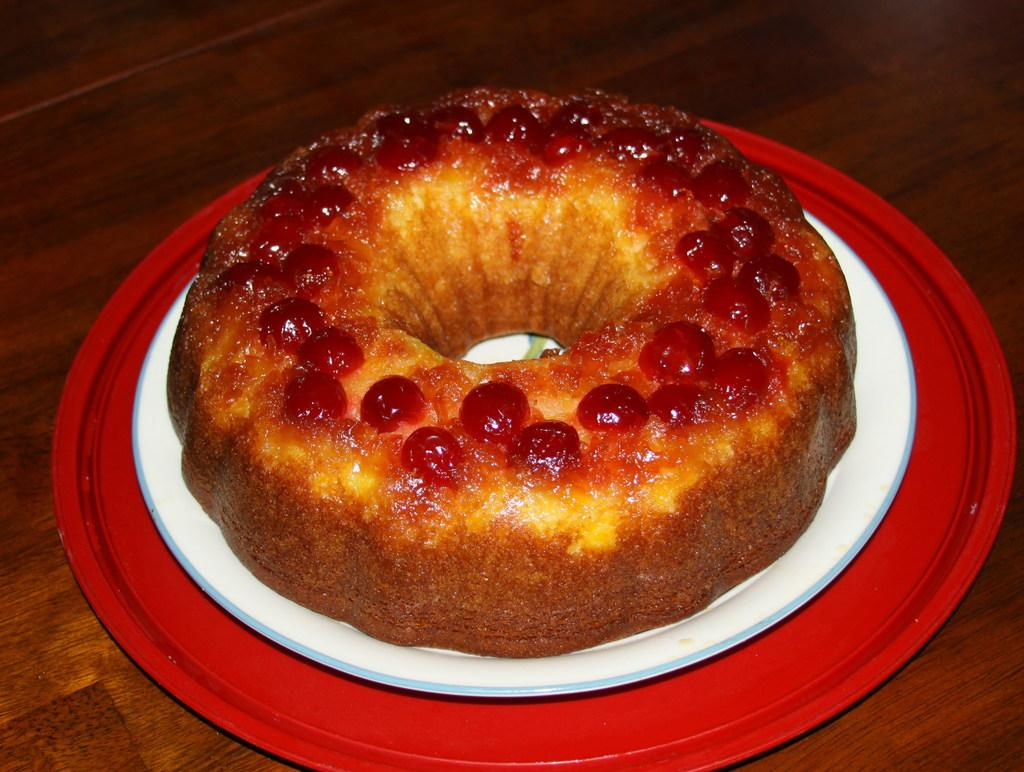What is the main subject of the image? The main subject of the image is food placed on a table. Can you describe the food in the image? Unfortunately, the facts provided do not give any specific details about the food. What might be the purpose of the table in the image? The table in the image is likely used for serving or displaying the food. How many houses are visible in the image? There are no houses visible in the image; it only shows food placed on a table. What type of addition problem can be solved using the food in the image? There is no addition problem present in the image, as it only shows food placed on a table. 